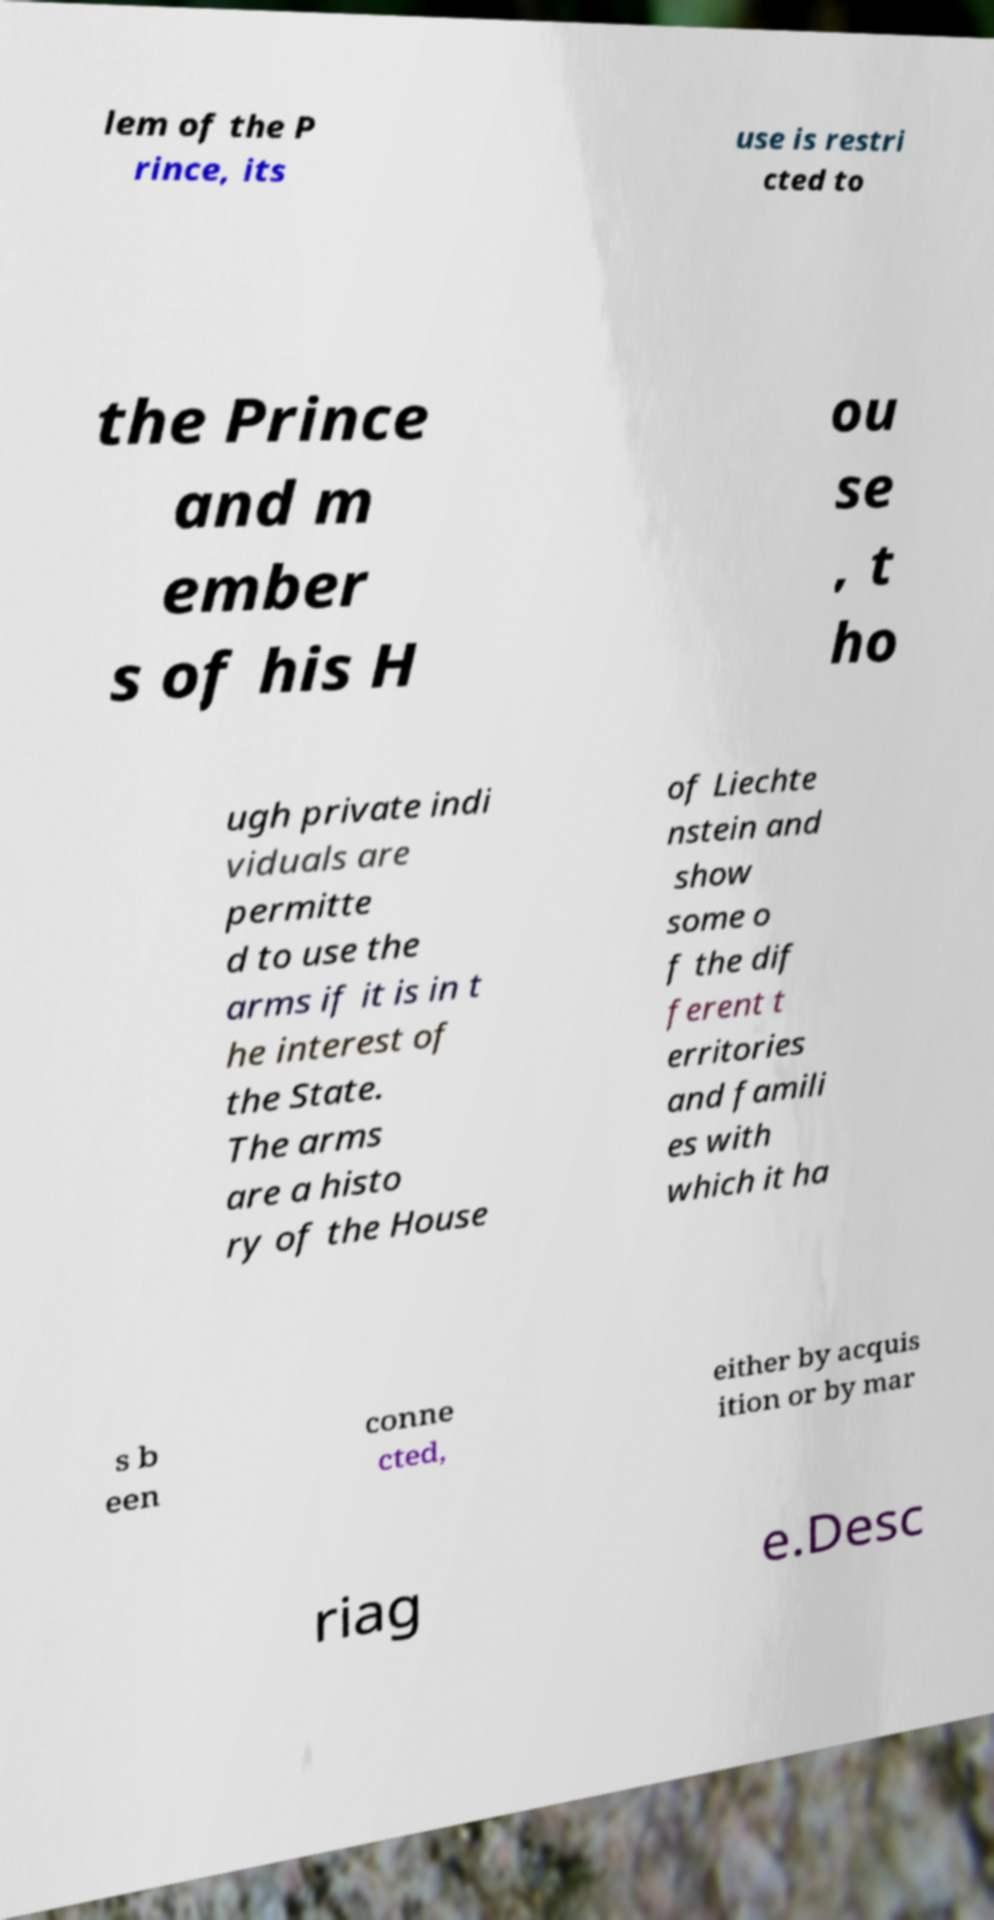Please identify and transcribe the text found in this image. lem of the P rince, its use is restri cted to the Prince and m ember s of his H ou se , t ho ugh private indi viduals are permitte d to use the arms if it is in t he interest of the State. The arms are a histo ry of the House of Liechte nstein and show some o f the dif ferent t erritories and famili es with which it ha s b een conne cted, either by acquis ition or by mar riag e.Desc 